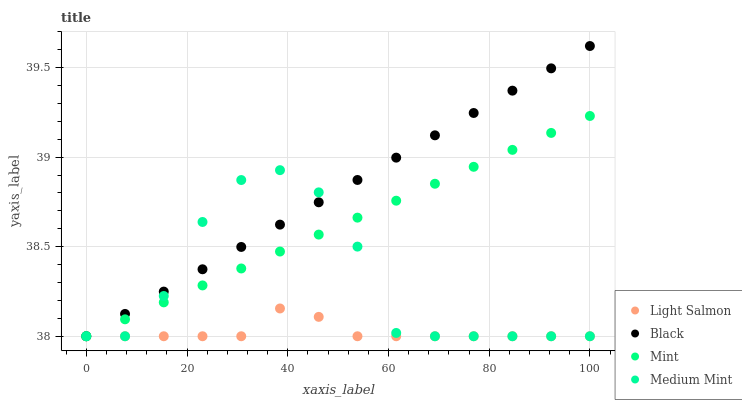Does Light Salmon have the minimum area under the curve?
Answer yes or no. Yes. Does Black have the maximum area under the curve?
Answer yes or no. Yes. Does Mint have the minimum area under the curve?
Answer yes or no. No. Does Mint have the maximum area under the curve?
Answer yes or no. No. Is Black the smoothest?
Answer yes or no. Yes. Is Medium Mint the roughest?
Answer yes or no. Yes. Is Mint the smoothest?
Answer yes or no. No. Is Mint the roughest?
Answer yes or no. No. Does Medium Mint have the lowest value?
Answer yes or no. Yes. Does Black have the highest value?
Answer yes or no. Yes. Does Mint have the highest value?
Answer yes or no. No. Does Light Salmon intersect Black?
Answer yes or no. Yes. Is Light Salmon less than Black?
Answer yes or no. No. Is Light Salmon greater than Black?
Answer yes or no. No. 